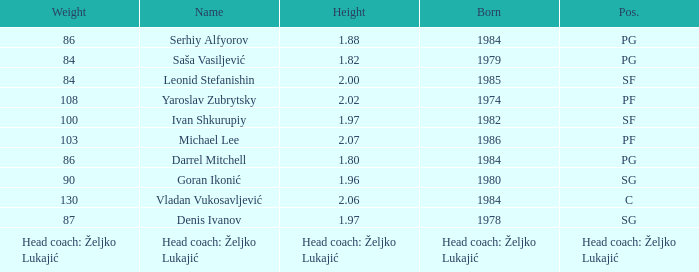What is the position of the player born in 1984 with a height of 1.80m? PG. Help me parse the entirety of this table. {'header': ['Weight', 'Name', 'Height', 'Born', 'Pos.'], 'rows': [['86', 'Serhiy Alfyorov', '1.88', '1984', 'PG'], ['84', 'Saša Vasiljević', '1.82', '1979', 'PG'], ['84', 'Leonid Stefanishin', '2.00', '1985', 'SF'], ['108', 'Yaroslav Zubrytsky', '2.02', '1974', 'PF'], ['100', 'Ivan Shkurupiy', '1.97', '1982', 'SF'], ['103', 'Michael Lee', '2.07', '1986', 'PF'], ['86', 'Darrel Mitchell', '1.80', '1984', 'PG'], ['90', 'Goran Ikonić', '1.96', '1980', 'SG'], ['130', 'Vladan Vukosavljević', '2.06', '1984', 'C'], ['87', 'Denis Ivanov', '1.97', '1978', 'SG'], ['Head coach: Željko Lukajić', 'Head coach: Željko Lukajić', 'Head coach: Željko Lukajić', 'Head coach: Željko Lukajić', 'Head coach: Željko Lukajić']]} 